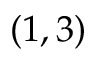Convert formula to latex. <formula><loc_0><loc_0><loc_500><loc_500>( 1 , 3 )</formula> 